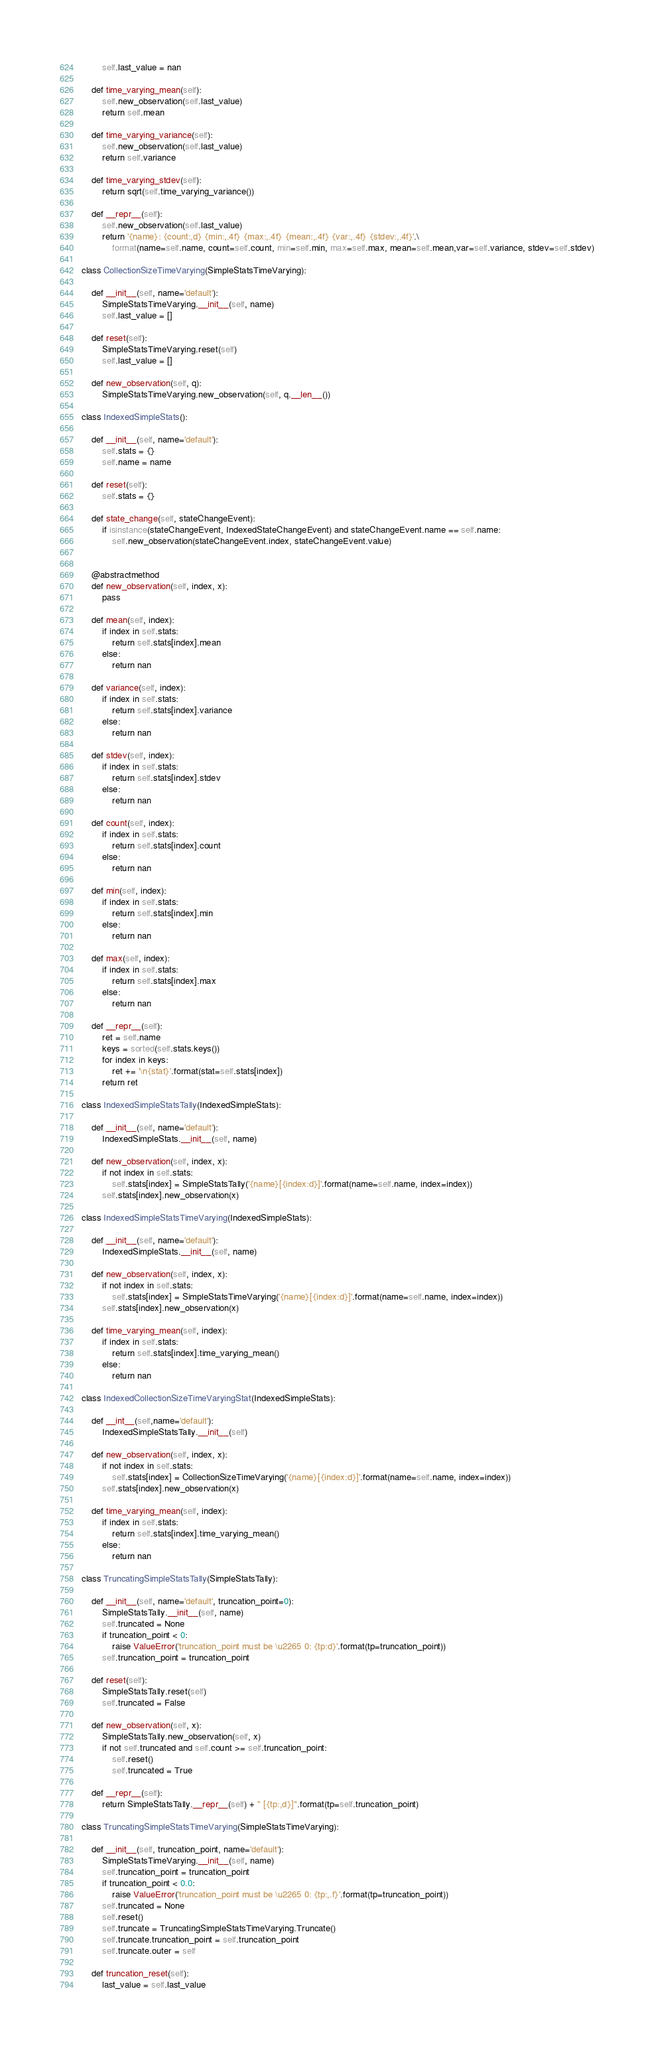Convert code to text. <code><loc_0><loc_0><loc_500><loc_500><_Python_>        self.last_value = nan

    def time_varying_mean(self):
        self.new_observation(self.last_value)
        return self.mean

    def time_varying_variance(self):
        self.new_observation(self.last_value)
        return self.variance

    def time_varying_stdev(self):
        return sqrt(self.time_varying_variance())

    def __repr__(self):
        self.new_observation(self.last_value)
        return '{name}: {count:,d} {min:,.4f} {max:,.4f} {mean:,.4f} {var:,.4f} {stdev:,.4f}'.\
            format(name=self.name, count=self.count, min=self.min, max=self.max, mean=self.mean,var=self.variance, stdev=self.stdev)

class CollectionSizeTimeVarying(SimpleStatsTimeVarying):

    def __init__(self, name='default'):
        SimpleStatsTimeVarying.__init__(self, name)
        self.last_value = []

    def reset(self):
        SimpleStatsTimeVarying.reset(self)
        self.last_value = []

    def new_observation(self, q):
        SimpleStatsTimeVarying.new_observation(self, q.__len__())

class IndexedSimpleStats():

    def __init__(self, name='default'):
        self.stats = {}
        self.name = name

    def reset(self):
        self.stats = {}

    def state_change(self, stateChangeEvent):
        if isinstance(stateChangeEvent, IndexedStateChangeEvent) and stateChangeEvent.name == self.name:
            self.new_observation(stateChangeEvent.index, stateChangeEvent.value)


    @abstractmethod
    def new_observation(self, index, x):
        pass

    def mean(self, index):
        if index in self.stats:
            return self.stats[index].mean
        else:
            return nan

    def variance(self, index):
        if index in self.stats:
            return self.stats[index].variance
        else:
            return nan

    def stdev(self, index):
        if index in self.stats:
            return self.stats[index].stdev
        else:
            return nan

    def count(self, index):
        if index in self.stats:
            return self.stats[index].count
        else:
            return nan

    def min(self, index):
        if index in self.stats:
            return self.stats[index].min
        else:
            return nan

    def max(self, index):
        if index in self.stats:
            return self.stats[index].max
        else:
            return nan

    def __repr__(self):
        ret = self.name
        keys = sorted(self.stats.keys())
        for index in keys:
            ret += '\n{stat}'.format(stat=self.stats[index])
        return ret

class IndexedSimpleStatsTally(IndexedSimpleStats):

    def __init__(self, name='default'):
        IndexedSimpleStats.__init__(self, name)

    def new_observation(self, index, x):
        if not index in self.stats:
            self.stats[index] = SimpleStatsTally('{name}[{index:d}]'.format(name=self.name, index=index))
        self.stats[index].new_observation(x)

class IndexedSimpleStatsTimeVarying(IndexedSimpleStats):

    def __init__(self, name='default'):
        IndexedSimpleStats.__init__(self, name)

    def new_observation(self, index, x):
        if not index in self.stats:
            self.stats[index] = SimpleStatsTimeVarying('{name}[{index:d}]'.format(name=self.name, index=index))
        self.stats[index].new_observation(x)

    def time_varying_mean(self, index):
        if index in self.stats:
            return self.stats[index].time_varying_mean()
        else:
            return nan

class IndexedCollectionSizeTimeVaryingStat(IndexedSimpleStats):

    def __int__(self,name='default'):
        IndexedSimpleStatsTally.__init__(self)

    def new_observation(self, index, x):
        if not index in self.stats:
            self.stats[index] = CollectionSizeTimeVarying('{name}[{index:d}]'.format(name=self.name, index=index))
        self.stats[index].new_observation(x)

    def time_varying_mean(self, index):
        if index in self.stats:
            return self.stats[index].time_varying_mean()
        else:
            return nan

class TruncatingSimpleStatsTally(SimpleStatsTally):

    def __init__(self, name='default', truncation_point=0):
        SimpleStatsTally.__init__(self, name)
        self.truncated = None
        if truncation_point < 0:
            raise ValueError('truncation_point must be \u2265 0: {tp:d}'.format(tp=truncation_point))
        self.truncation_point = truncation_point

    def reset(self):
        SimpleStatsTally.reset(self)
        self.truncated = False

    def new_observation(self, x):
        SimpleStatsTally.new_observation(self, x)
        if not self.truncated and self.count >= self.truncation_point:
            self.reset()
            self.truncated = True

    def __repr__(self):
        return SimpleStatsTally.__repr__(self) + " [{tp:,d}]".format(tp=self.truncation_point)

class TruncatingSimpleStatsTimeVarying(SimpleStatsTimeVarying):

    def __init__(self, truncation_point, name='default'):
        SimpleStatsTimeVarying.__init__(self, name)
        self.truncation_point = truncation_point
        if truncation_point < 0.0:
            raise ValueError('truncation_point must be \u2265 0: {tp:,.f}'.format(tp=truncation_point))
        self.truncated = None
        self.reset()
        self.truncate = TruncatingSimpleStatsTimeVarying.Truncate()
        self.truncate.truncation_point = self.truncation_point
        self.truncate.outer = self

    def truncation_reset(self):
        last_value = self.last_value</code> 